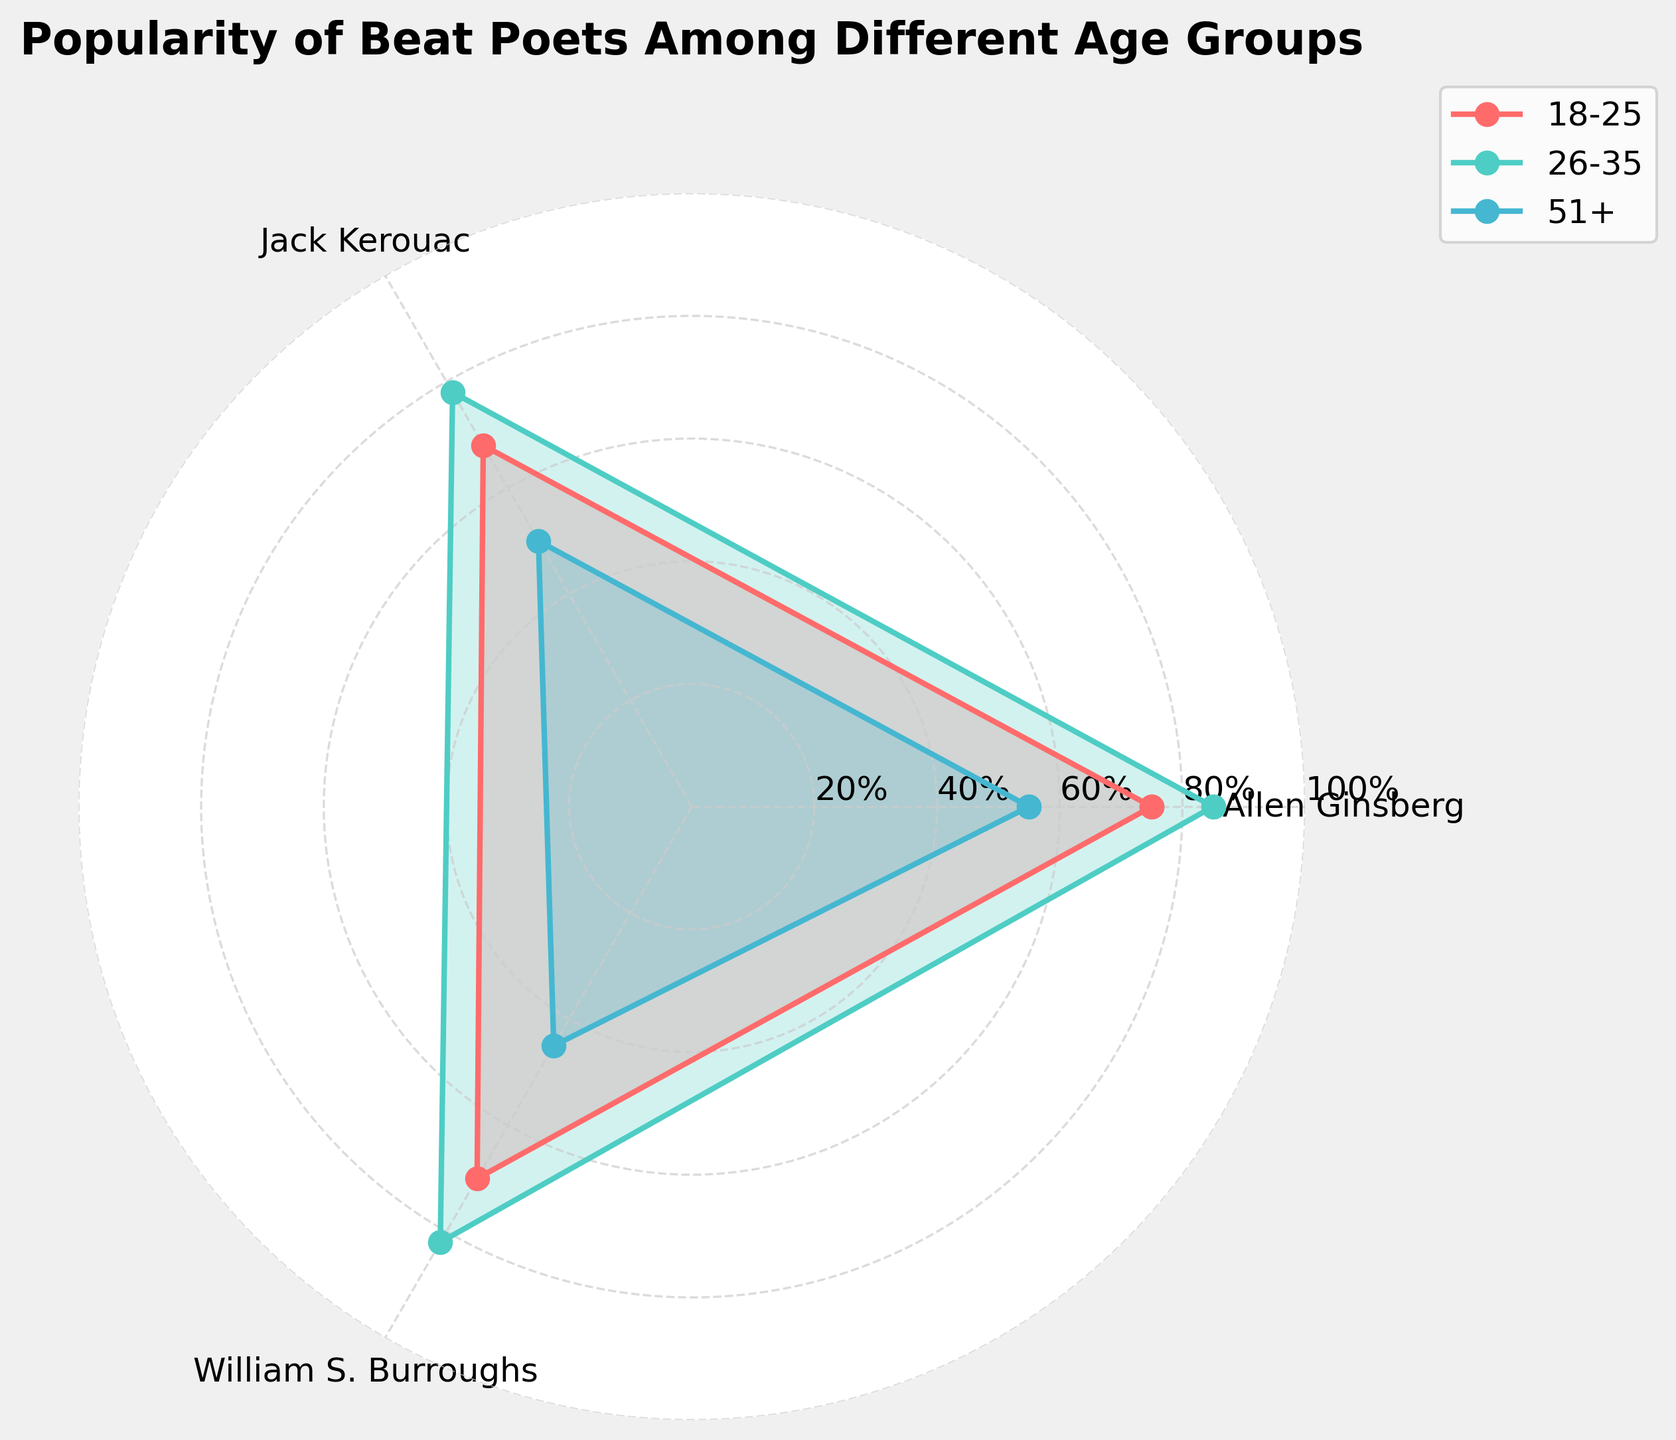What's the title of the figure? The title of the figure is generally placed at the top center. In this case, it reads "Popularity of Beat Poets Among Different Age Groups".
Answer: Popularity of Beat Poets Among Different Age Groups Which age group has the highest popularity for Allen Ginsberg? The angle corresponding to Allen Ginsberg has the highest value for the age group '26-35' based on the plot's lines and labels.
Answer: 26-35 What are the three age groups compared in the chart? The legend on the right side of the chart shows these age groups: ‘18-25’, ‘26-35’, and ‘51+’.
Answer: 18-25, 26-35, 51+ Which poet has the lowest popularity among the 51+ age group? For the age group '51+', the lowest value is closest to the center of the radar chart and corresponds to William S. Burroughs.
Answer: William S. Burroughs How does the popularity of Jack Kerouac compare between the '18-25' and '26-35' age groups? By comparing the radial distance from the center for Jack Kerouac for both age groups, '26-35' has a higher rating (78) compared to '18-25' (68).
Answer: '26-35' is higher Which poet has the most consistent popularity across the selected age groups? By observing the variation of the plot lines for each poet across the age groups, Allen Ginsberg maintains more consistent popularity as his lines show the least fluctuation.
Answer: Allen Ginsberg What is the average popularity rating for William S. Burroughs in the selected age groups? Summing up the popularity ratings for William S. Burroughs: 70 (18-25), 82 (26-35), and 45 (51+), we get 197. Dividing by 3 gives 65.67 (rounded to two decimal places).
Answer: 65.67 Which age group shows the greatest decline in popularity for William S. Burroughs when compared to the '26-35' group? Comparing the values of William S. Burroughs, '18-25' has a rating of 70, '26-35' has 82, and '51+' has 45. The greatest decline, calculated as 82 - 45 = 37, is from '26-35' to '51+'.
Answer: 51+ 